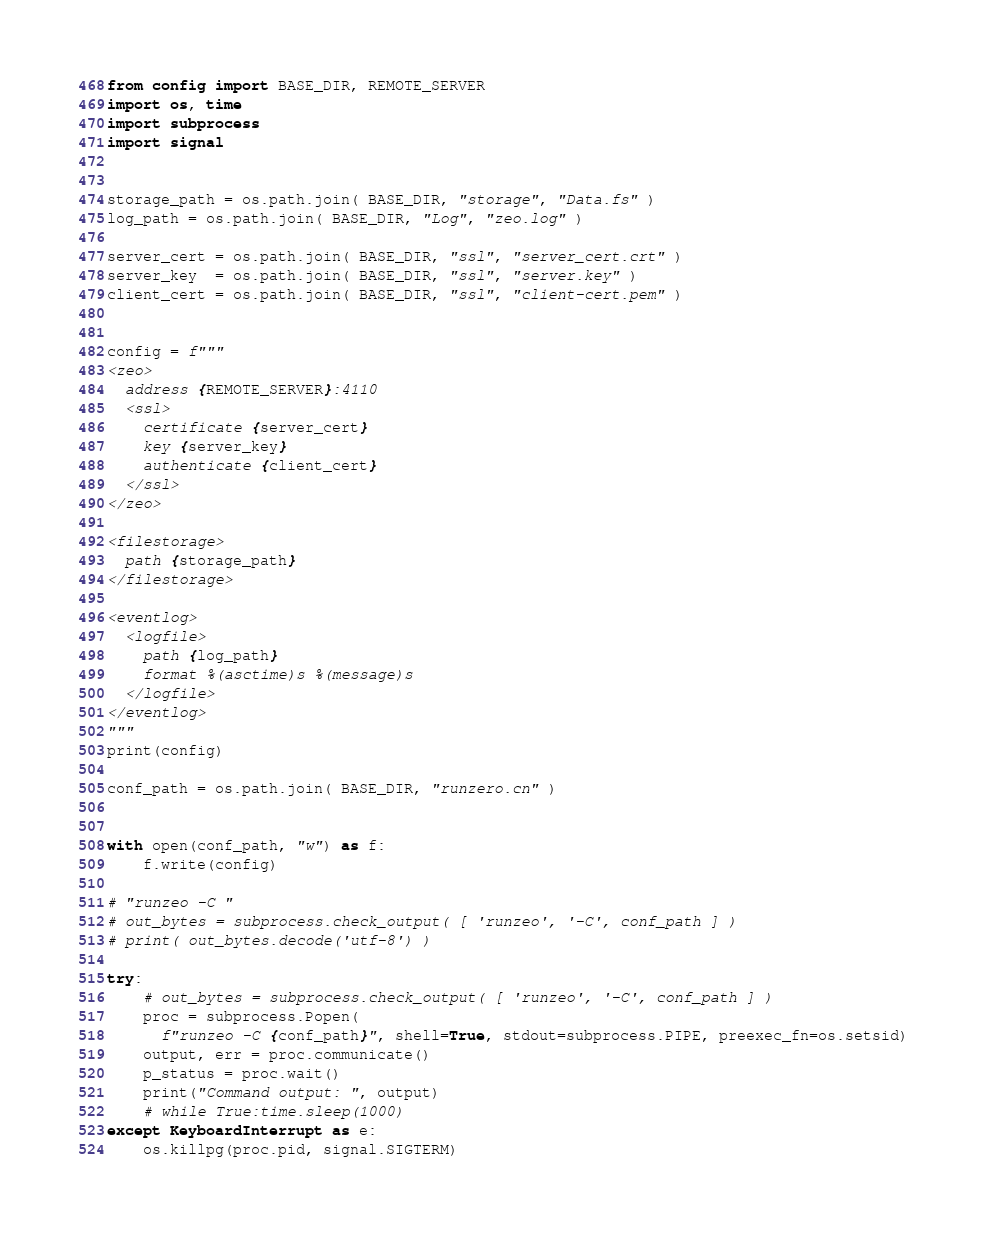<code> <loc_0><loc_0><loc_500><loc_500><_Python_>from config import BASE_DIR, REMOTE_SERVER
import os, time
import subprocess
import signal


storage_path = os.path.join( BASE_DIR, "storage", "Data.fs" )
log_path = os.path.join( BASE_DIR, "Log", "zeo.log" )

server_cert = os.path.join( BASE_DIR, "ssl", "server_cert.crt" )
server_key  = os.path.join( BASE_DIR, "ssl", "server.key" )
client_cert = os.path.join( BASE_DIR, "ssl", "client-cert.pem" )


config = f"""
<zeo>
  address {REMOTE_SERVER}:4110
  <ssl>
    certificate {server_cert}
    key {server_key}
    authenticate {client_cert}
  </ssl>
</zeo>

<filestorage>
  path {storage_path}
</filestorage>

<eventlog>
  <logfile>
    path {log_path}
    format %(asctime)s %(message)s
  </logfile>
</eventlog>
"""
print(config)

conf_path = os.path.join( BASE_DIR, "runzero.cn" )


with open(conf_path, "w") as f:
    f.write(config)

# "runzeo -C "
# out_bytes = subprocess.check_output( [ 'runzeo', '-C', conf_path ] )
# print( out_bytes.decode('utf-8') )

try:
    # out_bytes = subprocess.check_output( [ 'runzeo', '-C', conf_path ] )
    proc = subprocess.Popen(
      f"runzeo -C {conf_path}", shell=True, stdout=subprocess.PIPE, preexec_fn=os.setsid)
    output, err = proc.communicate()
    p_status = proc.wait()
    print("Command output: ", output)
    # while True:time.sleep(1000)
except KeyboardInterrupt as e:
    os.killpg(proc.pid, signal.SIGTERM)
</code> 